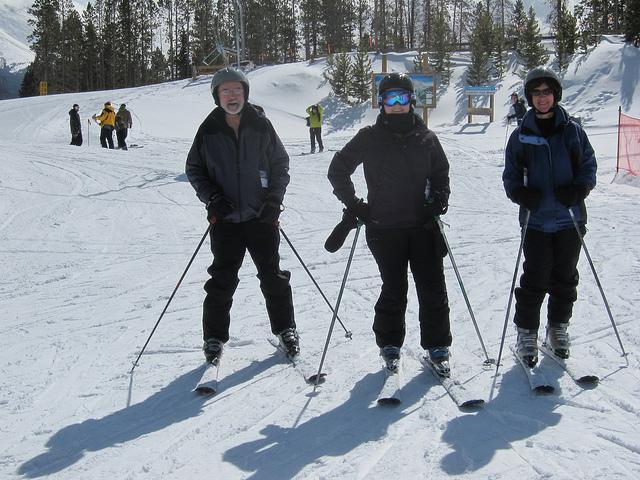How many people are there?
Give a very brief answer. 3. 